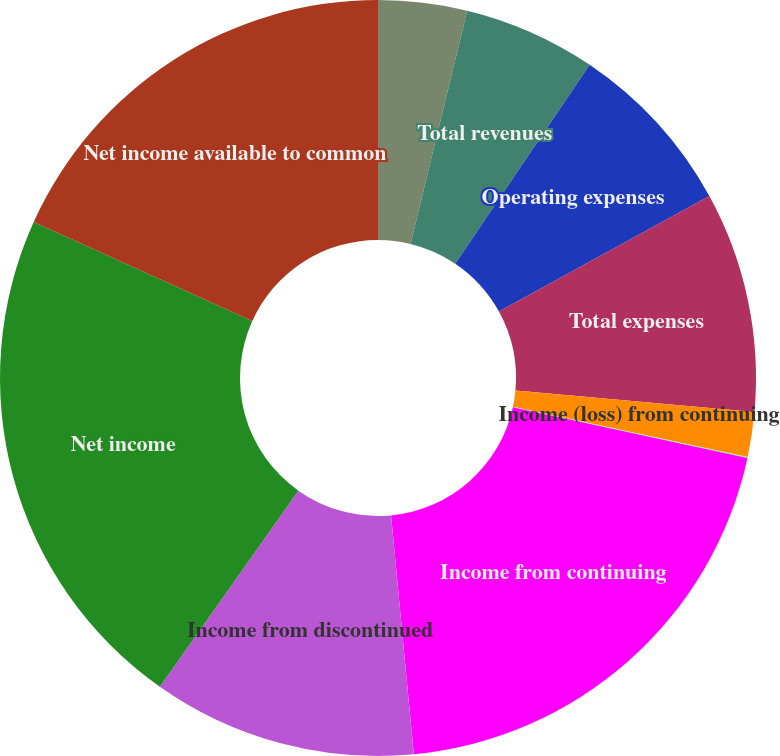Convert chart. <chart><loc_0><loc_0><loc_500><loc_500><pie_chart><fcel>Net investment income<fcel>Total revenues<fcel>Operating expenses<fcel>Total expenses<fcel>Income (loss) from continuing<fcel>Income taxes (benefits)<fcel>Income from continuing<fcel>Income from discontinued<fcel>Net income<fcel>Net income available to common<nl><fcel>3.79%<fcel>5.67%<fcel>7.55%<fcel>9.42%<fcel>1.92%<fcel>0.04%<fcel>20.1%<fcel>11.3%<fcel>21.98%<fcel>18.23%<nl></chart> 